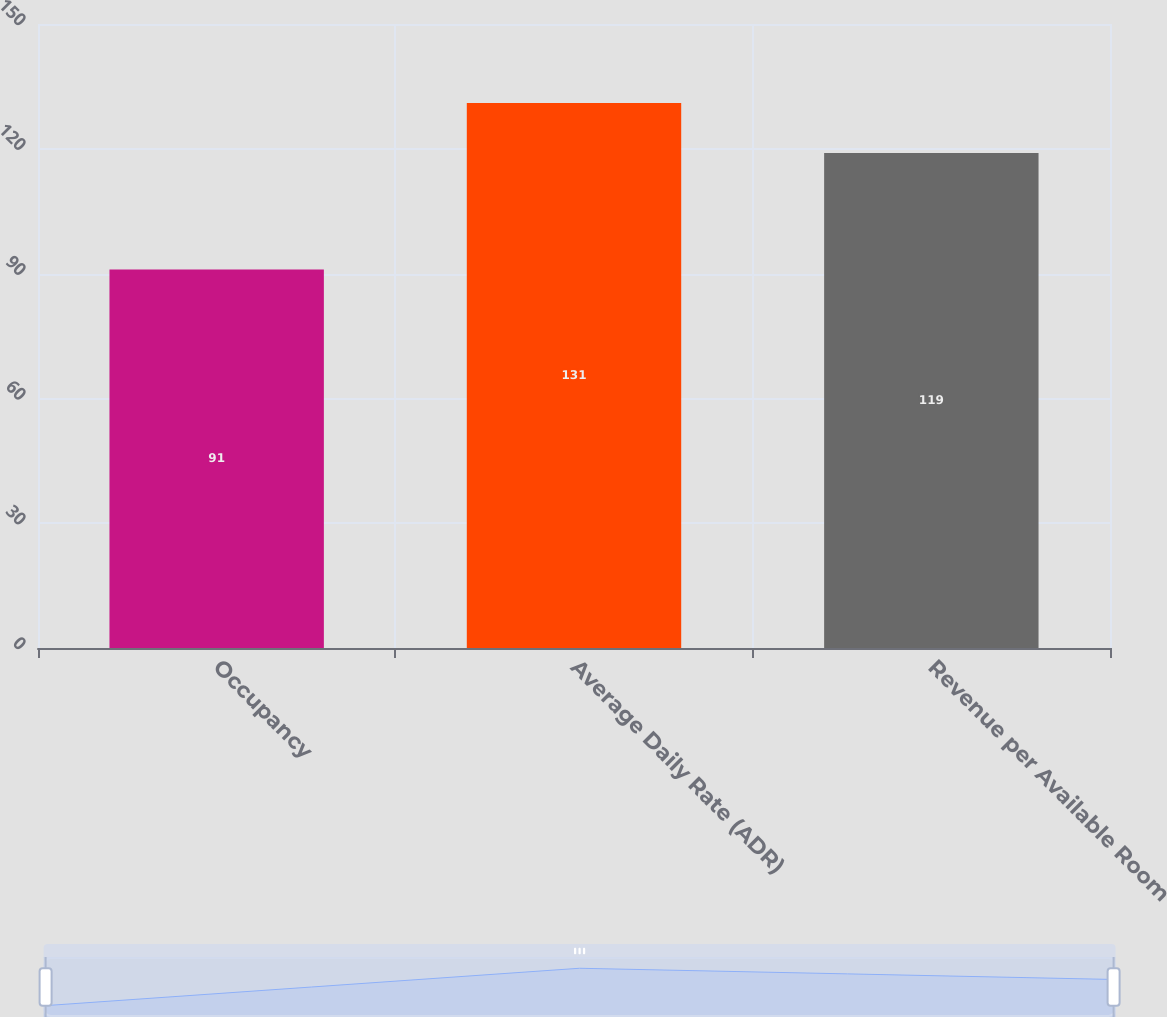Convert chart to OTSL. <chart><loc_0><loc_0><loc_500><loc_500><bar_chart><fcel>Occupancy<fcel>Average Daily Rate (ADR)<fcel>Revenue per Available Room<nl><fcel>91<fcel>131<fcel>119<nl></chart> 